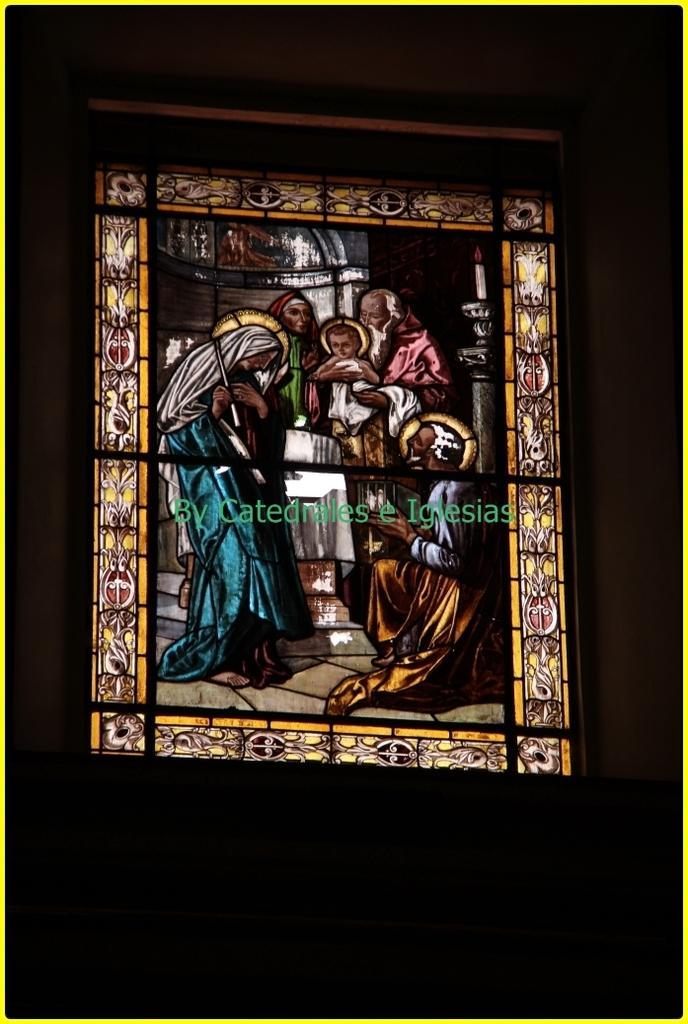In one or two sentences, can you explain what this image depicts? In this image we can see a glass painting with some text on it. 